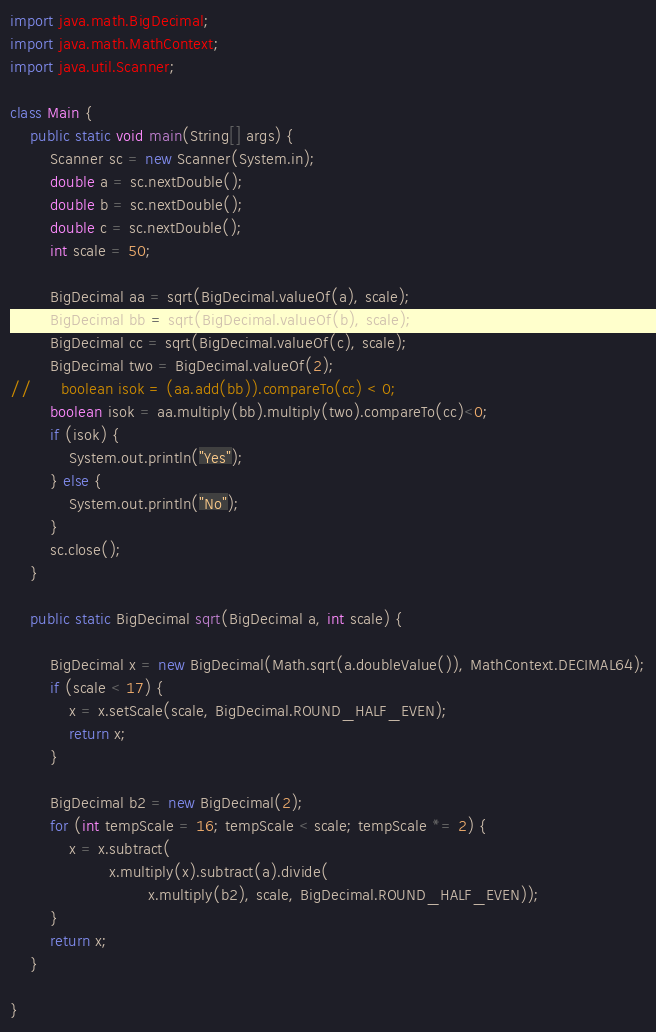Convert code to text. <code><loc_0><loc_0><loc_500><loc_500><_Java_>import java.math.BigDecimal;
import java.math.MathContext;
import java.util.Scanner;
 
class Main {
	public static void main(String[] args) {
		Scanner sc = new Scanner(System.in);
		double a = sc.nextDouble();
		double b = sc.nextDouble();
		double c = sc.nextDouble();
		int scale = 50;
 
		BigDecimal aa = sqrt(BigDecimal.valueOf(a), scale);
		BigDecimal bb = sqrt(BigDecimal.valueOf(b), scale);
		BigDecimal cc = sqrt(BigDecimal.valueOf(c), scale);
        BigDecimal two = BigDecimal.valueOf(2);
//		boolean isok = (aa.add(bb)).compareTo(cc) < 0;
        boolean isok = aa.multiply(bb).multiply(two).compareTo(cc)<0;
		if (isok) {
			System.out.println("Yes");
		} else {
			System.out.println("No");
		}
		sc.close();
	}
 
	public static BigDecimal sqrt(BigDecimal a, int scale) {
 
		BigDecimal x = new BigDecimal(Math.sqrt(a.doubleValue()), MathContext.DECIMAL64);
		if (scale < 17) {
			x = x.setScale(scale, BigDecimal.ROUND_HALF_EVEN);
			return x;
		}
 
		BigDecimal b2 = new BigDecimal(2);
		for (int tempScale = 16; tempScale < scale; tempScale *= 2) {
			x = x.subtract(
					x.multiply(x).subtract(a).divide(
							x.multiply(b2), scale, BigDecimal.ROUND_HALF_EVEN));
		}
		return x;
	}
 
}</code> 